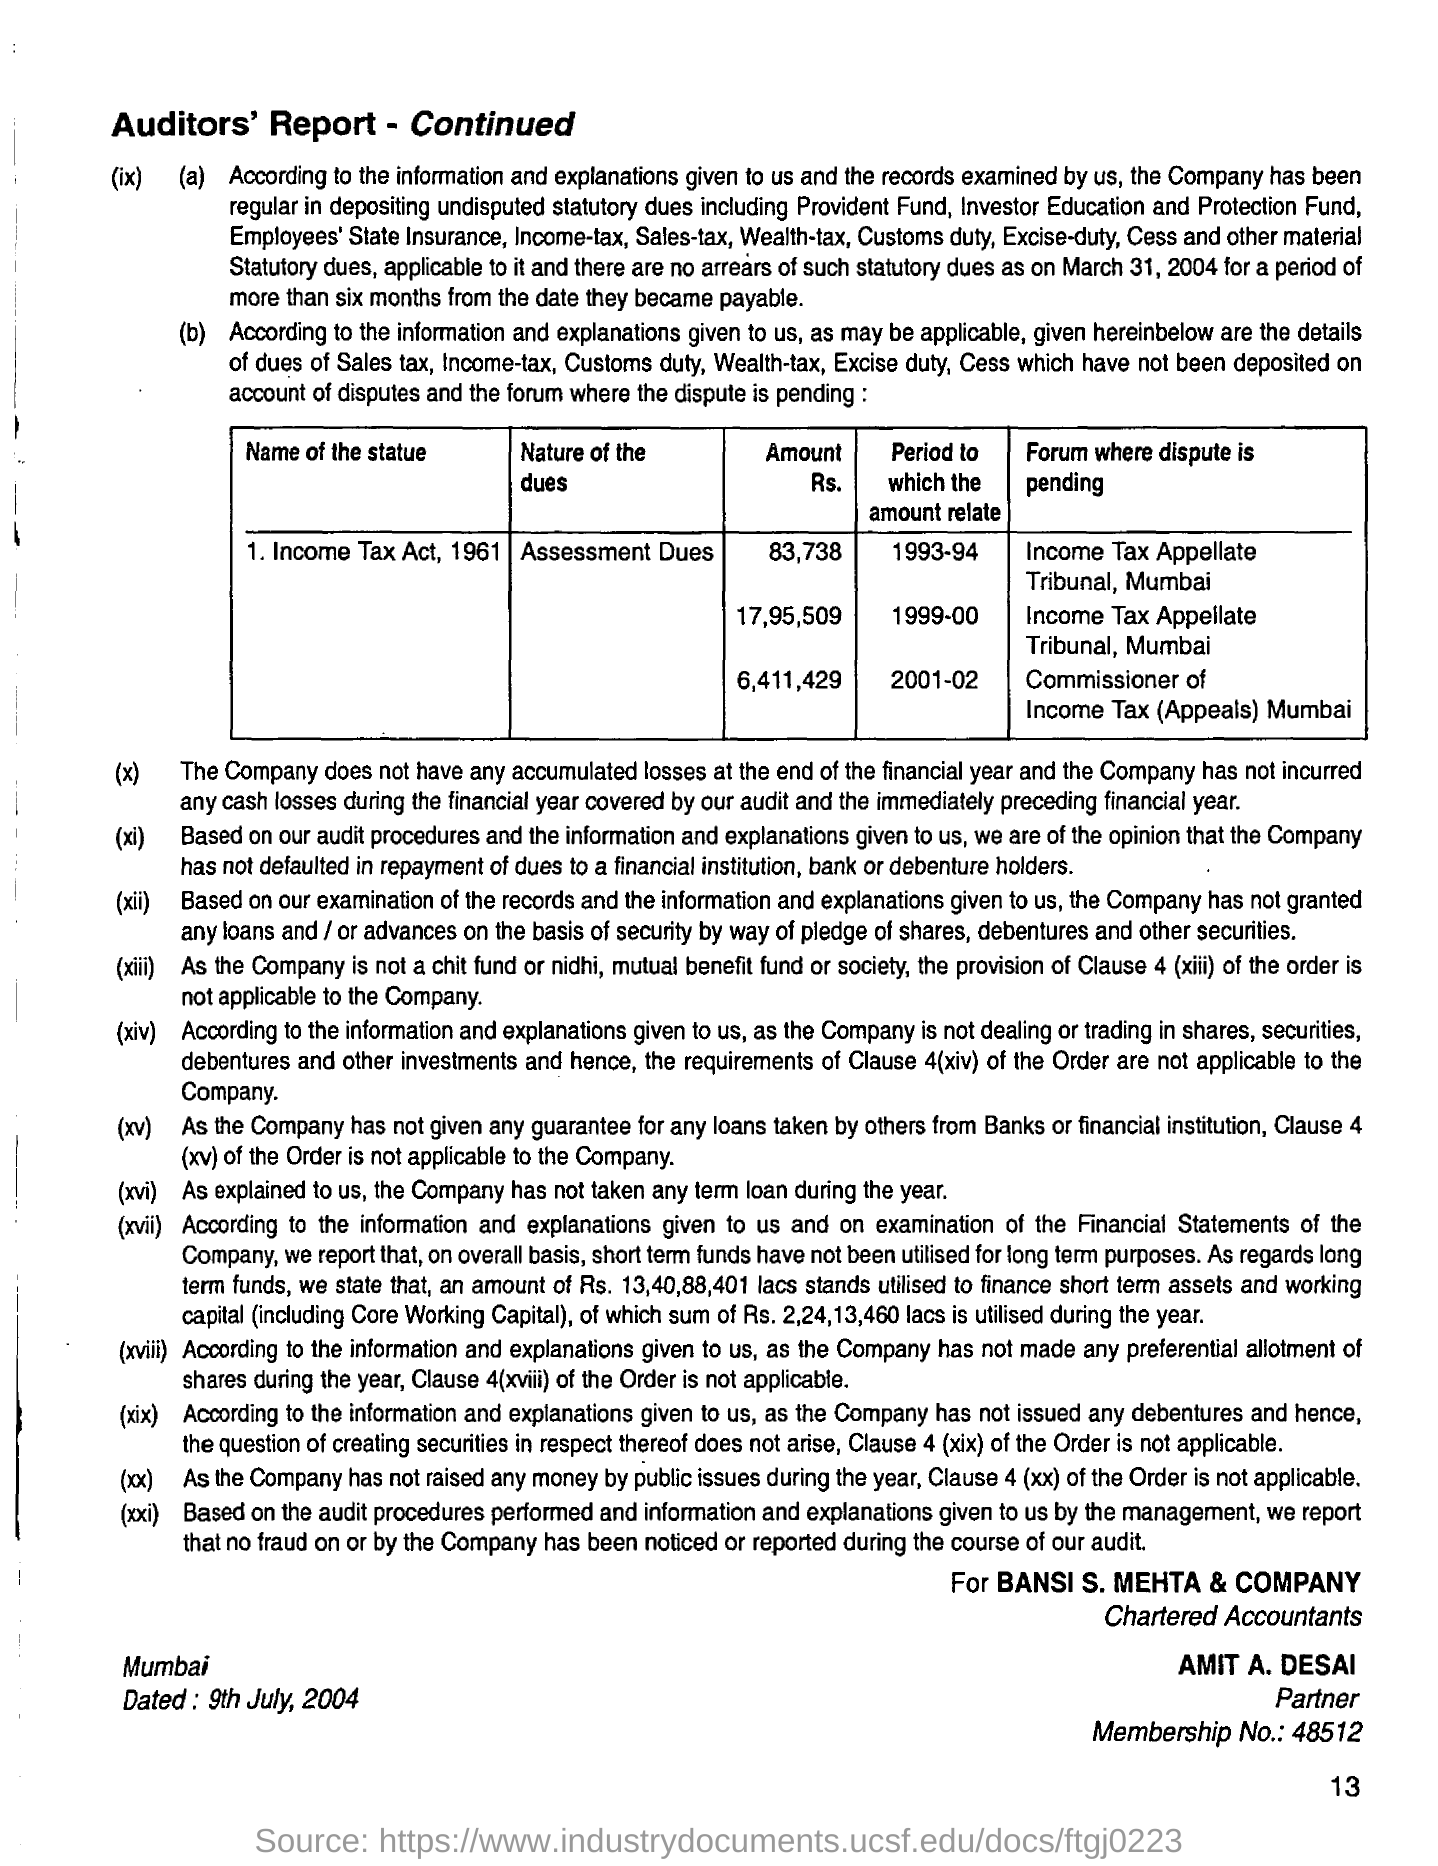What is the Name of the statue?
Provide a succinct answer. Income Tax Act, 1961. What is the Nature of the dues?
Offer a very short reply. Assessment Dues. What is the Place name on the document?
Keep it short and to the point. Mumbai. What is the Membership No.?
Give a very brief answer. 48512. Who is the Partner?
Provide a short and direct response. Amit A. Desai. 